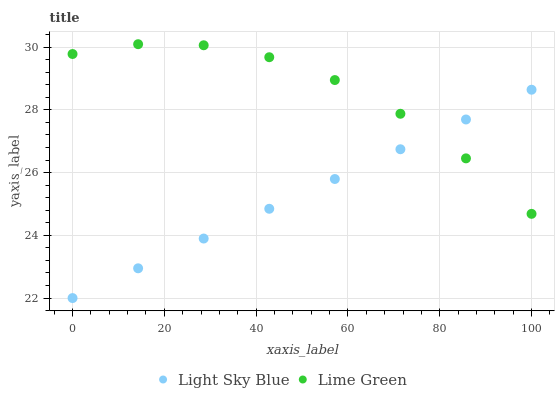Does Light Sky Blue have the minimum area under the curve?
Answer yes or no. Yes. Does Lime Green have the maximum area under the curve?
Answer yes or no. Yes. Does Lime Green have the minimum area under the curve?
Answer yes or no. No. Is Light Sky Blue the smoothest?
Answer yes or no. Yes. Is Lime Green the roughest?
Answer yes or no. Yes. Is Lime Green the smoothest?
Answer yes or no. No. Does Light Sky Blue have the lowest value?
Answer yes or no. Yes. Does Lime Green have the lowest value?
Answer yes or no. No. Does Lime Green have the highest value?
Answer yes or no. Yes. Does Lime Green intersect Light Sky Blue?
Answer yes or no. Yes. Is Lime Green less than Light Sky Blue?
Answer yes or no. No. Is Lime Green greater than Light Sky Blue?
Answer yes or no. No. 